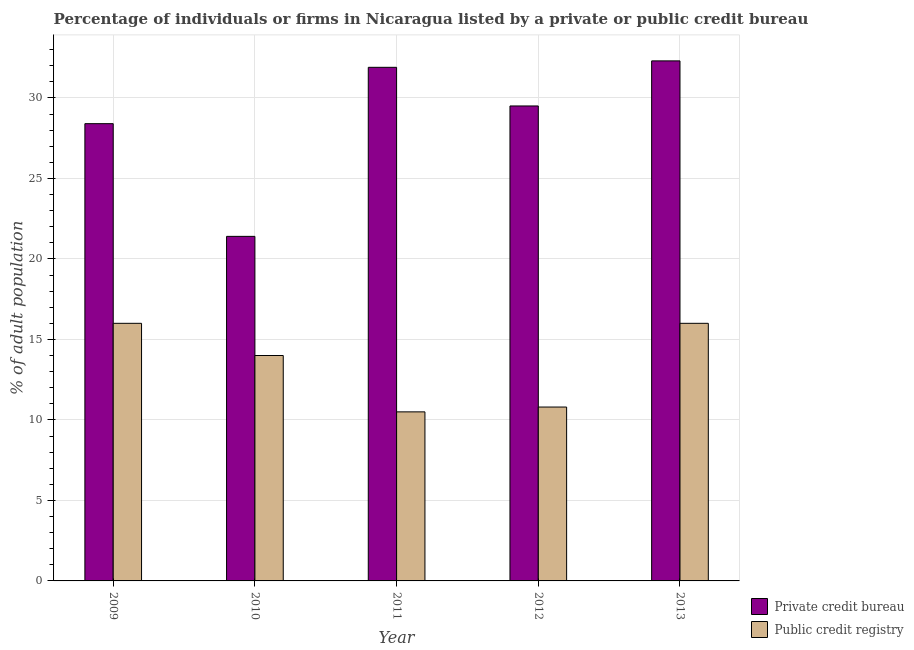How many different coloured bars are there?
Offer a very short reply. 2. How many groups of bars are there?
Offer a terse response. 5. Are the number of bars on each tick of the X-axis equal?
Make the answer very short. Yes. How many bars are there on the 3rd tick from the right?
Ensure brevity in your answer.  2. In how many cases, is the number of bars for a given year not equal to the number of legend labels?
Your response must be concise. 0. What is the percentage of firms listed by public credit bureau in 2010?
Provide a short and direct response. 14. Across all years, what is the maximum percentage of firms listed by public credit bureau?
Provide a short and direct response. 16. Across all years, what is the minimum percentage of firms listed by public credit bureau?
Provide a short and direct response. 10.5. What is the total percentage of firms listed by public credit bureau in the graph?
Offer a terse response. 67.3. What is the difference between the percentage of firms listed by public credit bureau in 2012 and that in 2013?
Keep it short and to the point. -5.2. What is the average percentage of firms listed by private credit bureau per year?
Give a very brief answer. 28.7. In the year 2009, what is the difference between the percentage of firms listed by public credit bureau and percentage of firms listed by private credit bureau?
Keep it short and to the point. 0. What is the ratio of the percentage of firms listed by private credit bureau in 2011 to that in 2013?
Provide a short and direct response. 0.99. Is the percentage of firms listed by public credit bureau in 2011 less than that in 2012?
Provide a succinct answer. Yes. Is the difference between the percentage of firms listed by private credit bureau in 2009 and 2013 greater than the difference between the percentage of firms listed by public credit bureau in 2009 and 2013?
Make the answer very short. No. What does the 1st bar from the left in 2010 represents?
Provide a succinct answer. Private credit bureau. What does the 2nd bar from the right in 2011 represents?
Your answer should be compact. Private credit bureau. How many bars are there?
Make the answer very short. 10. Are all the bars in the graph horizontal?
Your answer should be compact. No. How many years are there in the graph?
Your response must be concise. 5. What is the difference between two consecutive major ticks on the Y-axis?
Provide a short and direct response. 5. Does the graph contain grids?
Your answer should be very brief. Yes. How many legend labels are there?
Give a very brief answer. 2. How are the legend labels stacked?
Your answer should be compact. Vertical. What is the title of the graph?
Make the answer very short. Percentage of individuals or firms in Nicaragua listed by a private or public credit bureau. Does "Male labourers" appear as one of the legend labels in the graph?
Offer a very short reply. No. What is the label or title of the X-axis?
Offer a terse response. Year. What is the label or title of the Y-axis?
Your answer should be compact. % of adult population. What is the % of adult population of Private credit bureau in 2009?
Ensure brevity in your answer.  28.4. What is the % of adult population in Public credit registry in 2009?
Ensure brevity in your answer.  16. What is the % of adult population in Private credit bureau in 2010?
Make the answer very short. 21.4. What is the % of adult population in Public credit registry in 2010?
Offer a terse response. 14. What is the % of adult population of Private credit bureau in 2011?
Provide a short and direct response. 31.9. What is the % of adult population in Private credit bureau in 2012?
Provide a succinct answer. 29.5. What is the % of adult population in Public credit registry in 2012?
Your answer should be compact. 10.8. What is the % of adult population in Private credit bureau in 2013?
Provide a short and direct response. 32.3. Across all years, what is the maximum % of adult population in Private credit bureau?
Your answer should be compact. 32.3. Across all years, what is the minimum % of adult population in Private credit bureau?
Your answer should be compact. 21.4. Across all years, what is the minimum % of adult population of Public credit registry?
Your response must be concise. 10.5. What is the total % of adult population in Private credit bureau in the graph?
Provide a short and direct response. 143.5. What is the total % of adult population in Public credit registry in the graph?
Make the answer very short. 67.3. What is the difference between the % of adult population in Private credit bureau in 2009 and that in 2010?
Give a very brief answer. 7. What is the difference between the % of adult population of Private credit bureau in 2009 and that in 2011?
Make the answer very short. -3.5. What is the difference between the % of adult population of Public credit registry in 2009 and that in 2011?
Offer a terse response. 5.5. What is the difference between the % of adult population of Private credit bureau in 2010 and that in 2013?
Your answer should be compact. -10.9. What is the difference between the % of adult population of Public credit registry in 2011 and that in 2012?
Your response must be concise. -0.3. What is the difference between the % of adult population in Private credit bureau in 2011 and that in 2013?
Offer a very short reply. -0.4. What is the difference between the % of adult population of Private credit bureau in 2012 and that in 2013?
Offer a terse response. -2.8. What is the difference between the % of adult population in Public credit registry in 2012 and that in 2013?
Your response must be concise. -5.2. What is the difference between the % of adult population of Private credit bureau in 2009 and the % of adult population of Public credit registry in 2010?
Give a very brief answer. 14.4. What is the difference between the % of adult population of Private credit bureau in 2009 and the % of adult population of Public credit registry in 2012?
Offer a very short reply. 17.6. What is the difference between the % of adult population in Private credit bureau in 2010 and the % of adult population in Public credit registry in 2011?
Offer a very short reply. 10.9. What is the difference between the % of adult population in Private credit bureau in 2010 and the % of adult population in Public credit registry in 2013?
Provide a succinct answer. 5.4. What is the difference between the % of adult population of Private credit bureau in 2011 and the % of adult population of Public credit registry in 2012?
Your response must be concise. 21.1. What is the average % of adult population in Private credit bureau per year?
Keep it short and to the point. 28.7. What is the average % of adult population of Public credit registry per year?
Ensure brevity in your answer.  13.46. In the year 2009, what is the difference between the % of adult population in Private credit bureau and % of adult population in Public credit registry?
Offer a terse response. 12.4. In the year 2011, what is the difference between the % of adult population of Private credit bureau and % of adult population of Public credit registry?
Offer a terse response. 21.4. In the year 2013, what is the difference between the % of adult population of Private credit bureau and % of adult population of Public credit registry?
Make the answer very short. 16.3. What is the ratio of the % of adult population of Private credit bureau in 2009 to that in 2010?
Make the answer very short. 1.33. What is the ratio of the % of adult population of Public credit registry in 2009 to that in 2010?
Give a very brief answer. 1.14. What is the ratio of the % of adult population of Private credit bureau in 2009 to that in 2011?
Provide a succinct answer. 0.89. What is the ratio of the % of adult population in Public credit registry in 2009 to that in 2011?
Offer a terse response. 1.52. What is the ratio of the % of adult population in Private credit bureau in 2009 to that in 2012?
Keep it short and to the point. 0.96. What is the ratio of the % of adult population in Public credit registry in 2009 to that in 2012?
Keep it short and to the point. 1.48. What is the ratio of the % of adult population of Private credit bureau in 2009 to that in 2013?
Ensure brevity in your answer.  0.88. What is the ratio of the % of adult population in Public credit registry in 2009 to that in 2013?
Provide a succinct answer. 1. What is the ratio of the % of adult population in Private credit bureau in 2010 to that in 2011?
Offer a terse response. 0.67. What is the ratio of the % of adult population in Public credit registry in 2010 to that in 2011?
Your response must be concise. 1.33. What is the ratio of the % of adult population in Private credit bureau in 2010 to that in 2012?
Offer a very short reply. 0.73. What is the ratio of the % of adult population of Public credit registry in 2010 to that in 2012?
Offer a very short reply. 1.3. What is the ratio of the % of adult population of Private credit bureau in 2010 to that in 2013?
Offer a very short reply. 0.66. What is the ratio of the % of adult population of Public credit registry in 2010 to that in 2013?
Give a very brief answer. 0.88. What is the ratio of the % of adult population in Private credit bureau in 2011 to that in 2012?
Keep it short and to the point. 1.08. What is the ratio of the % of adult population in Public credit registry in 2011 to that in 2012?
Ensure brevity in your answer.  0.97. What is the ratio of the % of adult population in Private credit bureau in 2011 to that in 2013?
Your answer should be compact. 0.99. What is the ratio of the % of adult population in Public credit registry in 2011 to that in 2013?
Keep it short and to the point. 0.66. What is the ratio of the % of adult population of Private credit bureau in 2012 to that in 2013?
Keep it short and to the point. 0.91. What is the ratio of the % of adult population of Public credit registry in 2012 to that in 2013?
Your response must be concise. 0.68. What is the difference between the highest and the second highest % of adult population of Private credit bureau?
Your answer should be compact. 0.4. What is the difference between the highest and the lowest % of adult population of Private credit bureau?
Provide a short and direct response. 10.9. What is the difference between the highest and the lowest % of adult population of Public credit registry?
Offer a terse response. 5.5. 